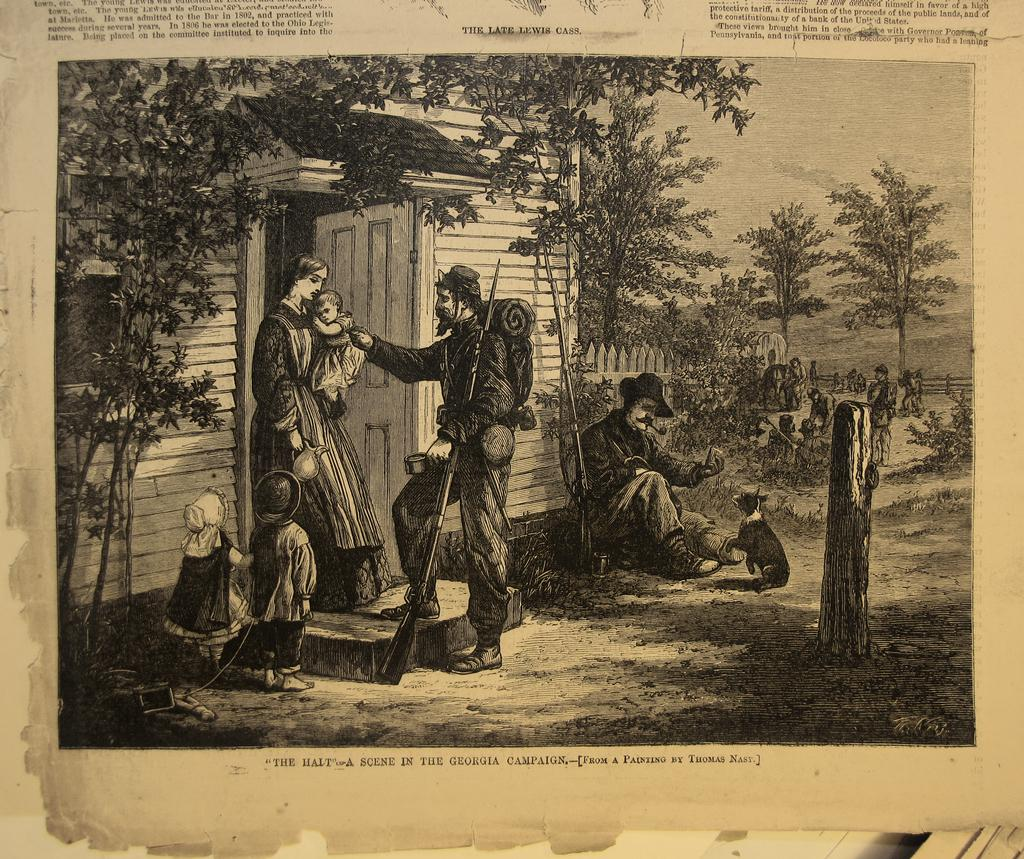What is the main subject of the paper in the image? The paper contains images of people, an animal, a house, trees, and the sky. Can you describe the images on the paper? The paper contains images of people, an animal, a house, trees, and the sky. Is there any text on the paper? Yes, there is text written on the paper. What type of secretary can be seen working in the town depicted on the paper? There is no town or secretary depicted on the paper; it contains images of people, an animal, a house, trees, and the sky. What type of pickle is used to decorate the house in the image? There is no pickle present in the image; it contains images of people, an animal, a house, trees, and the sky. 